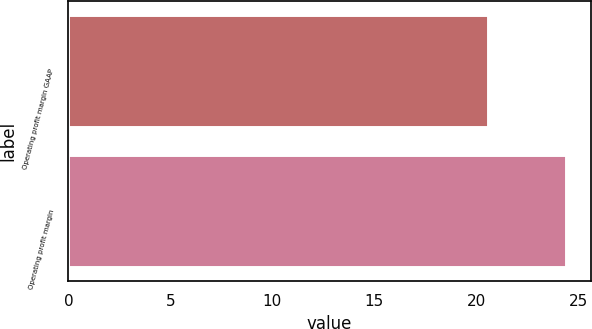Convert chart to OTSL. <chart><loc_0><loc_0><loc_500><loc_500><bar_chart><fcel>Operating profit margin GAAP<fcel>Operating profit margin<nl><fcel>20.6<fcel>24.4<nl></chart> 